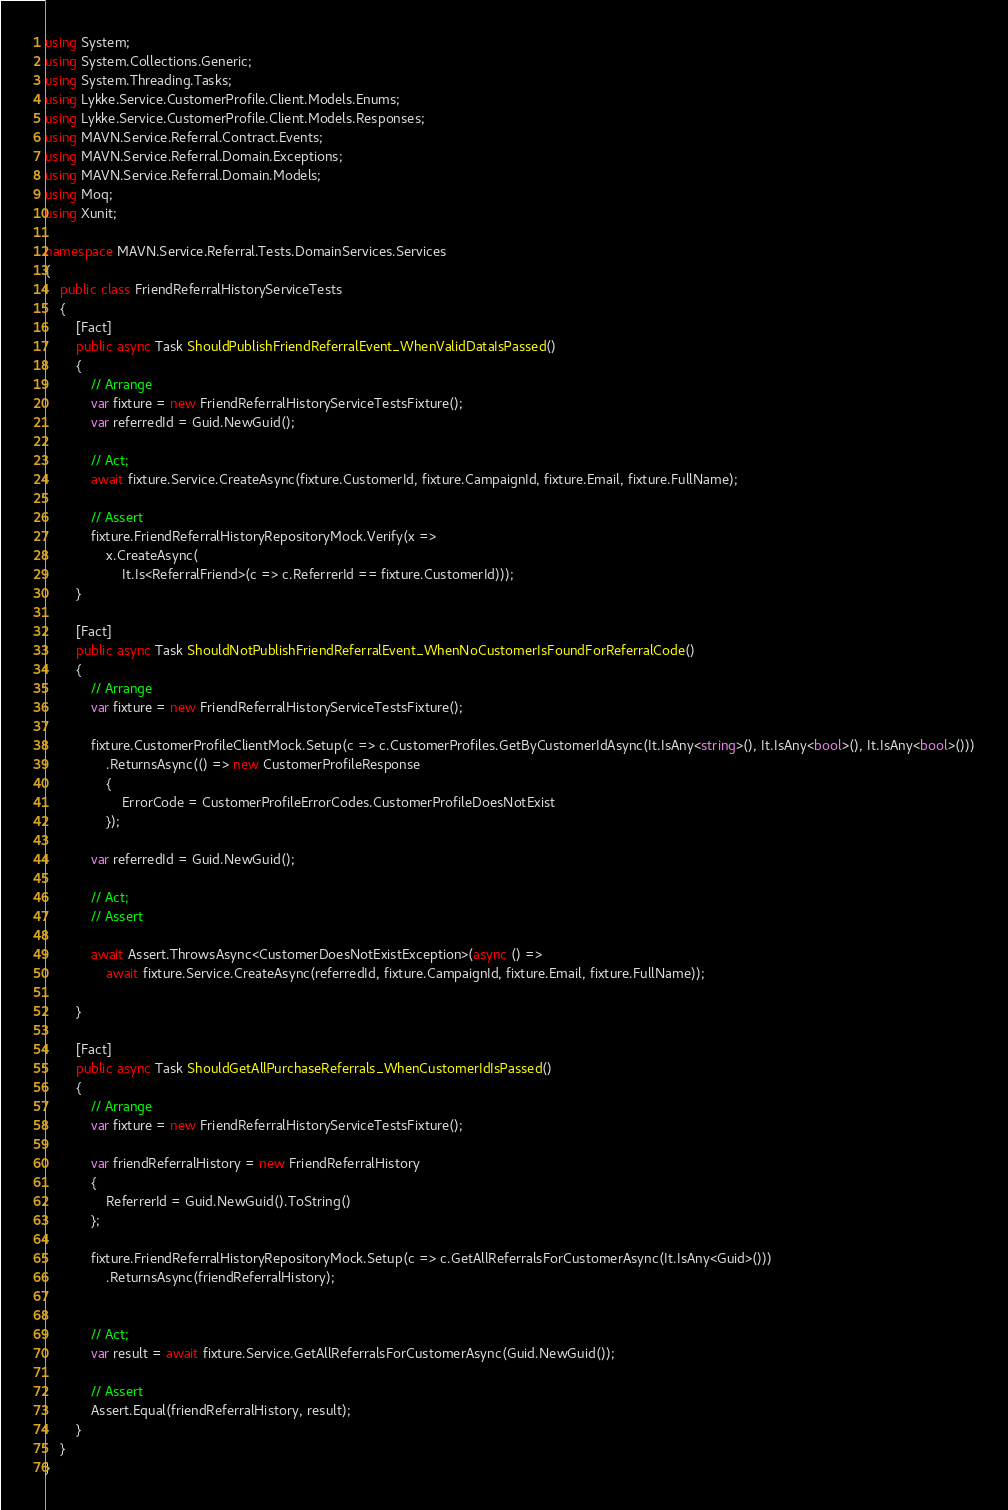<code> <loc_0><loc_0><loc_500><loc_500><_C#_>using System;
using System.Collections.Generic;
using System.Threading.Tasks;
using Lykke.Service.CustomerProfile.Client.Models.Enums;
using Lykke.Service.CustomerProfile.Client.Models.Responses;
using MAVN.Service.Referral.Contract.Events;
using MAVN.Service.Referral.Domain.Exceptions;
using MAVN.Service.Referral.Domain.Models;
using Moq;
using Xunit;

namespace MAVN.Service.Referral.Tests.DomainServices.Services
{
    public class FriendReferralHistoryServiceTests
    {
        [Fact]
        public async Task ShouldPublishFriendReferralEvent_WhenValidDataIsPassed()
        {
            // Arrange
            var fixture = new FriendReferralHistoryServiceTestsFixture();
            var referredId = Guid.NewGuid();

            // Act;
            await fixture.Service.CreateAsync(fixture.CustomerId, fixture.CampaignId, fixture.Email, fixture.FullName);

            // Assert
            fixture.FriendReferralHistoryRepositoryMock.Verify(x =>
                x.CreateAsync(
                    It.Is<ReferralFriend>(c => c.ReferrerId == fixture.CustomerId)));
        }

        [Fact]
        public async Task ShouldNotPublishFriendReferralEvent_WhenNoCustomerIsFoundForReferralCode()
        {
            // Arrange
            var fixture = new FriendReferralHistoryServiceTestsFixture();

            fixture.CustomerProfileClientMock.Setup(c => c.CustomerProfiles.GetByCustomerIdAsync(It.IsAny<string>(), It.IsAny<bool>(), It.IsAny<bool>()))
                .ReturnsAsync(() => new CustomerProfileResponse
                {
                    ErrorCode = CustomerProfileErrorCodes.CustomerProfileDoesNotExist
                });

            var referredId = Guid.NewGuid();

            // Act;
            // Assert

            await Assert.ThrowsAsync<CustomerDoesNotExistException>(async () =>
                await fixture.Service.CreateAsync(referredId, fixture.CampaignId, fixture.Email, fixture.FullName));

        }

        [Fact]
        public async Task ShouldGetAllPurchaseReferrals_WhenCustomerIdIsPassed()
        {
            // Arrange
            var fixture = new FriendReferralHistoryServiceTestsFixture();

            var friendReferralHistory = new FriendReferralHistory
            {
                ReferrerId = Guid.NewGuid().ToString()
            };

            fixture.FriendReferralHistoryRepositoryMock.Setup(c => c.GetAllReferralsForCustomerAsync(It.IsAny<Guid>()))
                .ReturnsAsync(friendReferralHistory);


            // Act;
            var result = await fixture.Service.GetAllReferralsForCustomerAsync(Guid.NewGuid());

            // Assert
            Assert.Equal(friendReferralHistory, result);
        }
    }
}
</code> 